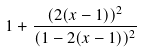<formula> <loc_0><loc_0><loc_500><loc_500>1 + \frac { ( 2 ( x - 1 ) ) ^ { 2 } } { ( 1 - 2 ( x - 1 ) ) ^ { 2 } }</formula> 